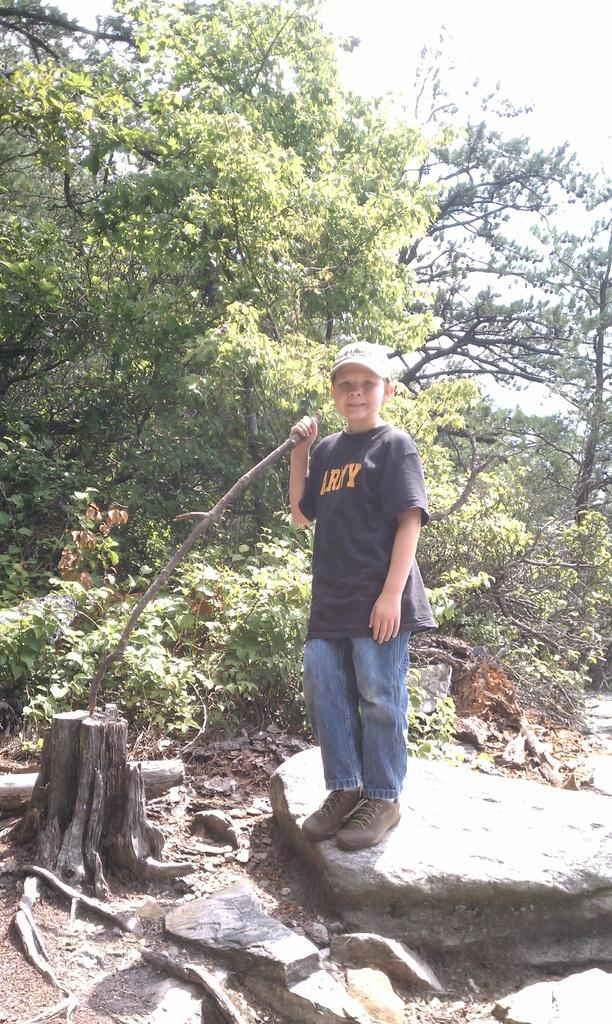Who is present in the image? There is a boy in the image. What is the boy wearing on his head? The boy is wearing a cap. What is the boy holding in his hand? The boy is holding a branch. What can be seen in the background of the image? There are trees, plants, and the sky visible in the background of the image. What type of waste can be seen in the image? There is no waste present in the image. What tool is the boy using to rake leaves in the image? The boy is not using a rake or any tool to rake leaves in the image; he is holding a branch. 